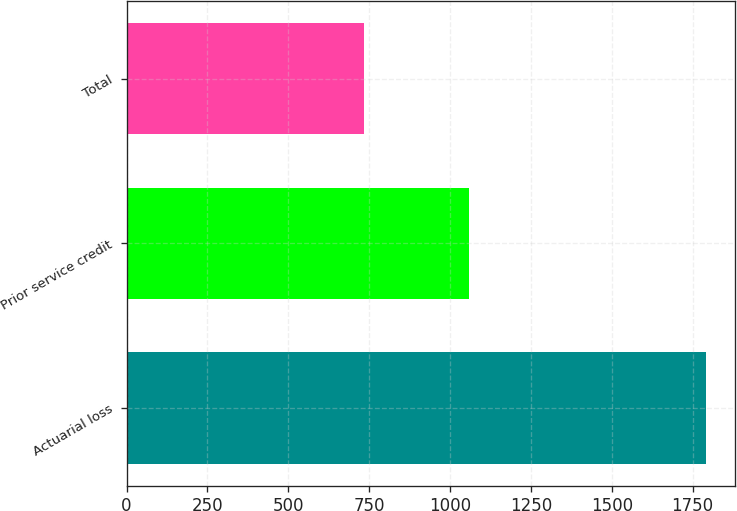<chart> <loc_0><loc_0><loc_500><loc_500><bar_chart><fcel>Actuarial loss<fcel>Prior service credit<fcel>Total<nl><fcel>1792<fcel>1059<fcel>733<nl></chart> 